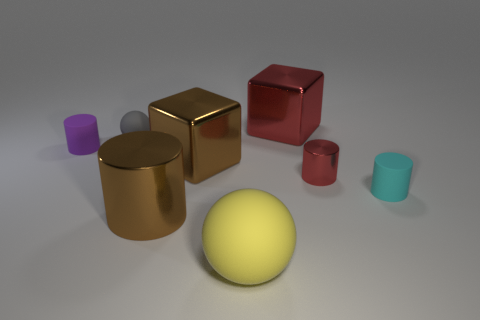What number of gray objects have the same material as the big red block?
Give a very brief answer. 0. Is the cyan object the same size as the yellow ball?
Make the answer very short. No. Is there any other thing of the same color as the large rubber thing?
Ensure brevity in your answer.  No. The object that is both behind the purple cylinder and right of the gray ball has what shape?
Offer a terse response. Cube. There is a rubber cylinder that is left of the gray ball; how big is it?
Your answer should be very brief. Small. How many large brown objects are left of the large brown metal object that is in front of the shiny cube that is in front of the small purple rubber cylinder?
Offer a very short reply. 0. Are there any small purple things in front of the purple cylinder?
Your answer should be compact. No. How many other things are there of the same size as the brown shiny cylinder?
Offer a very short reply. 3. What is the object that is both on the left side of the yellow matte thing and in front of the large brown metal cube made of?
Offer a very short reply. Metal. There is a brown thing that is in front of the small cyan object; is it the same shape as the big brown metal object behind the tiny cyan rubber cylinder?
Make the answer very short. No. 